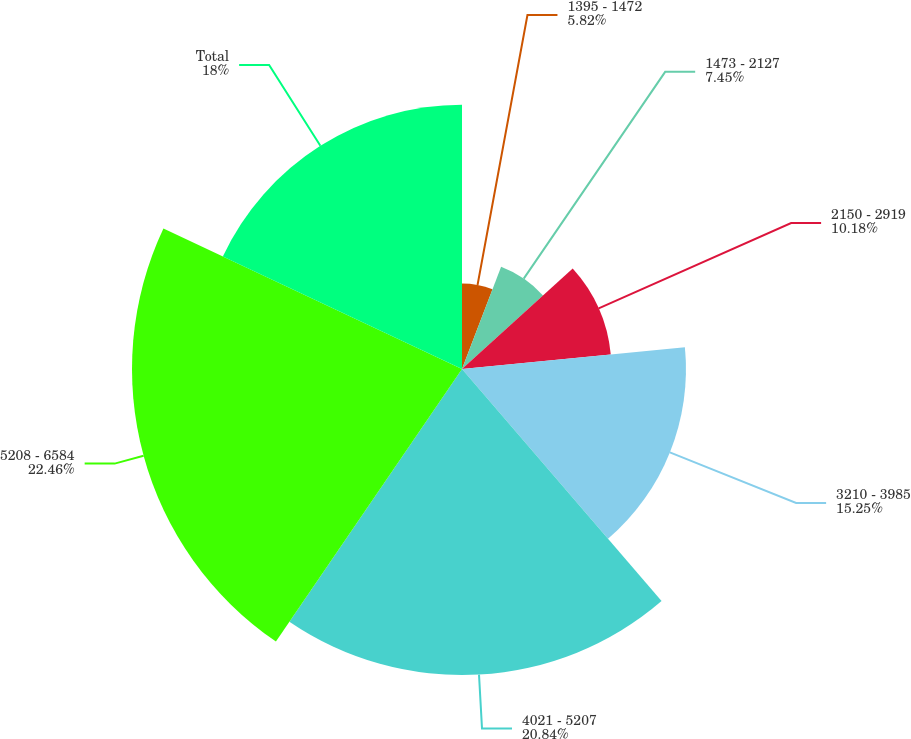Convert chart to OTSL. <chart><loc_0><loc_0><loc_500><loc_500><pie_chart><fcel>1395 - 1472<fcel>1473 - 2127<fcel>2150 - 2919<fcel>3210 - 3985<fcel>4021 - 5207<fcel>5208 - 6584<fcel>Total<nl><fcel>5.82%<fcel>7.45%<fcel>10.18%<fcel>15.25%<fcel>20.84%<fcel>22.47%<fcel>18.0%<nl></chart> 